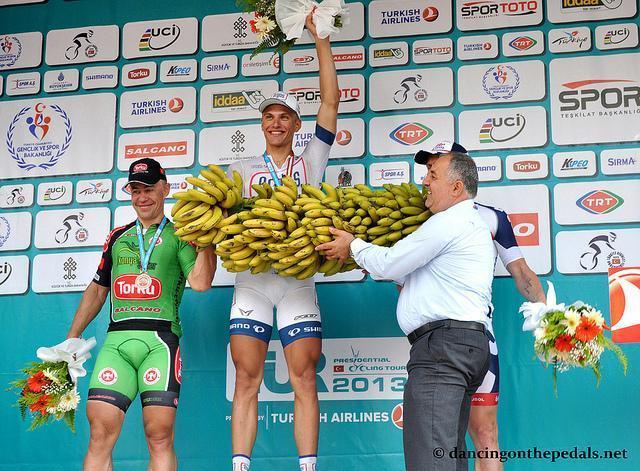How many bananas are there?
Give a very brief answer. 3. How many people are there?
Give a very brief answer. 4. 